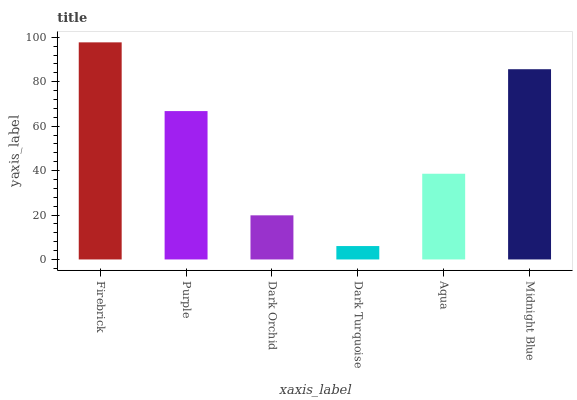Is Dark Turquoise the minimum?
Answer yes or no. Yes. Is Firebrick the maximum?
Answer yes or no. Yes. Is Purple the minimum?
Answer yes or no. No. Is Purple the maximum?
Answer yes or no. No. Is Firebrick greater than Purple?
Answer yes or no. Yes. Is Purple less than Firebrick?
Answer yes or no. Yes. Is Purple greater than Firebrick?
Answer yes or no. No. Is Firebrick less than Purple?
Answer yes or no. No. Is Purple the high median?
Answer yes or no. Yes. Is Aqua the low median?
Answer yes or no. Yes. Is Midnight Blue the high median?
Answer yes or no. No. Is Midnight Blue the low median?
Answer yes or no. No. 